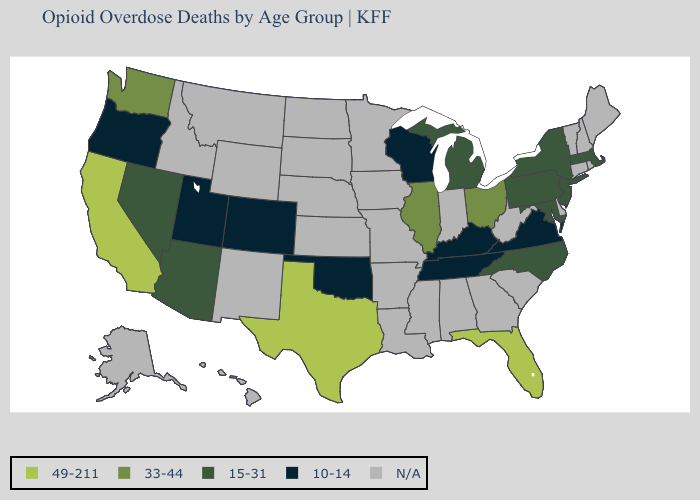What is the value of Illinois?
Be succinct. 33-44. Name the states that have a value in the range 49-211?
Give a very brief answer. California, Florida, Texas. Is the legend a continuous bar?
Write a very short answer. No. Name the states that have a value in the range N/A?
Quick response, please. Alabama, Alaska, Arkansas, Connecticut, Delaware, Georgia, Hawaii, Idaho, Indiana, Iowa, Kansas, Louisiana, Maine, Minnesota, Mississippi, Missouri, Montana, Nebraska, New Hampshire, New Mexico, North Dakota, Rhode Island, South Carolina, South Dakota, Vermont, West Virginia, Wyoming. Name the states that have a value in the range N/A?
Be succinct. Alabama, Alaska, Arkansas, Connecticut, Delaware, Georgia, Hawaii, Idaho, Indiana, Iowa, Kansas, Louisiana, Maine, Minnesota, Mississippi, Missouri, Montana, Nebraska, New Hampshire, New Mexico, North Dakota, Rhode Island, South Carolina, South Dakota, Vermont, West Virginia, Wyoming. Name the states that have a value in the range 33-44?
Write a very short answer. Illinois, Ohio, Washington. What is the highest value in the South ?
Be succinct. 49-211. Does California have the highest value in the USA?
Keep it brief. Yes. Among the states that border Georgia , does North Carolina have the highest value?
Keep it brief. No. Is the legend a continuous bar?
Write a very short answer. No. Name the states that have a value in the range 15-31?
Keep it brief. Arizona, Maryland, Massachusetts, Michigan, Nevada, New Jersey, New York, North Carolina, Pennsylvania. Name the states that have a value in the range N/A?
Short answer required. Alabama, Alaska, Arkansas, Connecticut, Delaware, Georgia, Hawaii, Idaho, Indiana, Iowa, Kansas, Louisiana, Maine, Minnesota, Mississippi, Missouri, Montana, Nebraska, New Hampshire, New Mexico, North Dakota, Rhode Island, South Carolina, South Dakota, Vermont, West Virginia, Wyoming. Among the states that border Connecticut , which have the lowest value?
Short answer required. Massachusetts, New York. Name the states that have a value in the range 49-211?
Keep it brief. California, Florida, Texas. 